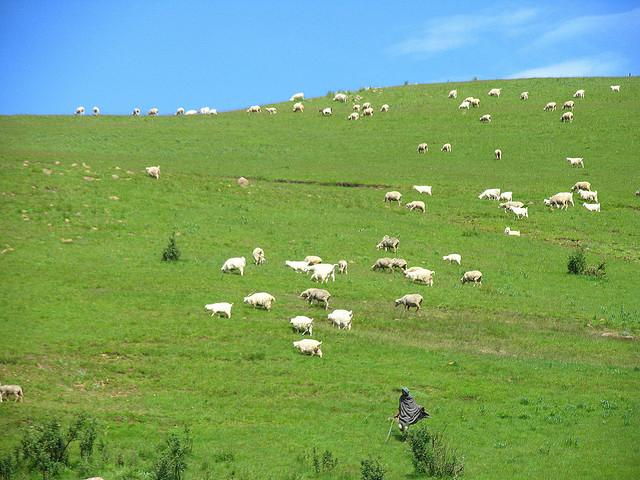What might the man be attempting to do with the animals? Please explain your reasoning. herd them. The photo includes a mountain side which has a lot of sheep scattered around.  there is a man in the foreground who is holding a staff and has a dog on the far left.  these are all signs that he is trying to herd them. 